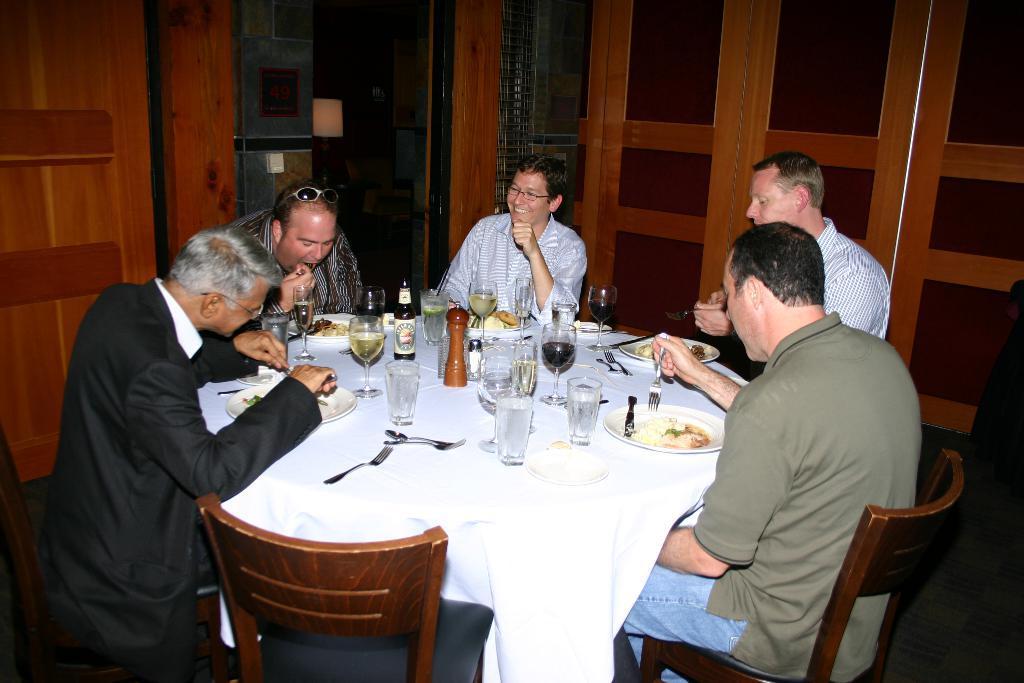How would you summarize this image in a sentence or two? In this image I see 5 men who are sitting on the chairs and there is a table in front and there are lot of glasses and plates and food in it. 